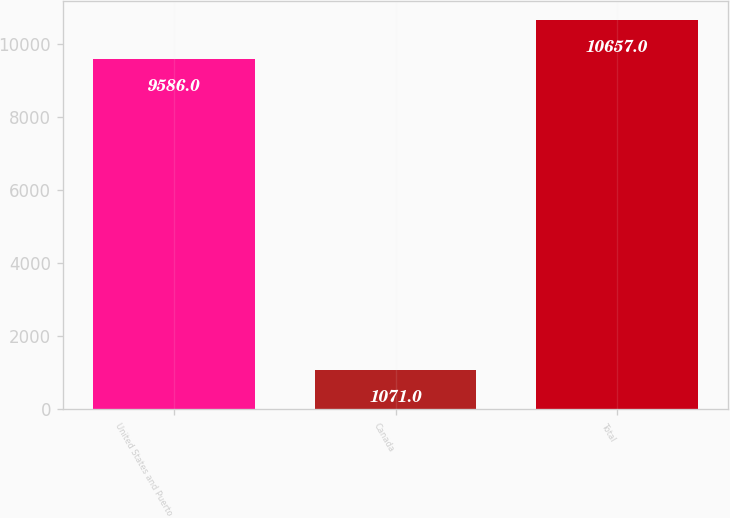Convert chart to OTSL. <chart><loc_0><loc_0><loc_500><loc_500><bar_chart><fcel>United States and Puerto<fcel>Canada<fcel>Total<nl><fcel>9586<fcel>1071<fcel>10657<nl></chart> 